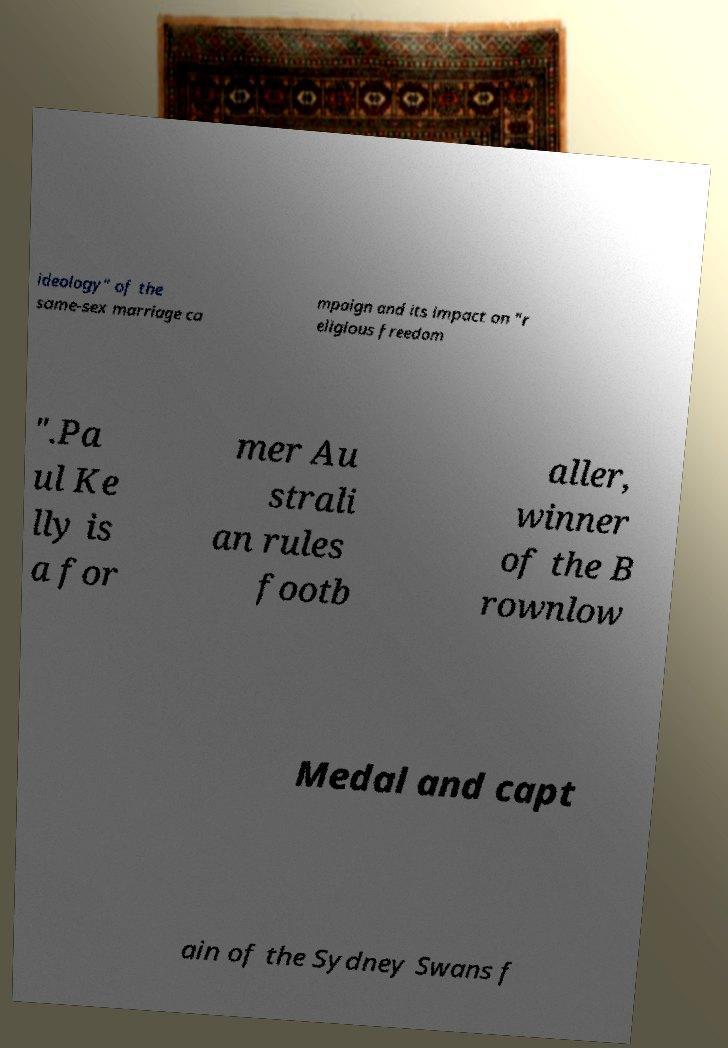I need the written content from this picture converted into text. Can you do that? ideology" of the same-sex marriage ca mpaign and its impact on "r eligious freedom ".Pa ul Ke lly is a for mer Au strali an rules footb aller, winner of the B rownlow Medal and capt ain of the Sydney Swans f 